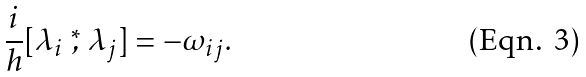Convert formula to latex. <formula><loc_0><loc_0><loc_500><loc_500>\frac { i } { h } [ \lambda _ { i } \stackrel { * } { , } \lambda _ { j } ] = - \omega _ { i j } .</formula> 